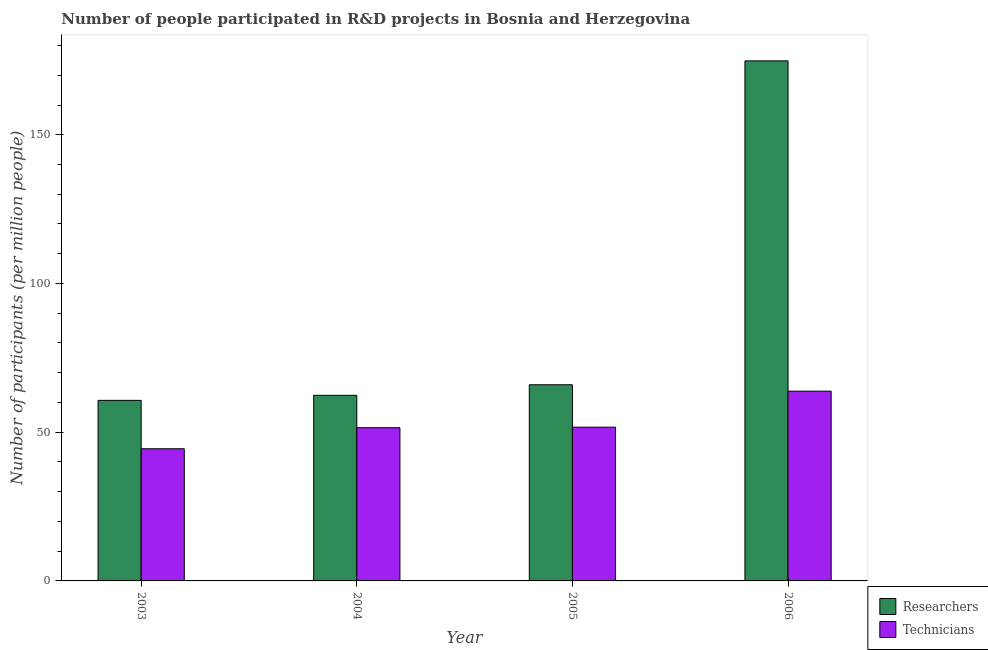Are the number of bars per tick equal to the number of legend labels?
Make the answer very short. Yes. How many bars are there on the 2nd tick from the left?
Offer a terse response. 2. How many bars are there on the 3rd tick from the right?
Provide a succinct answer. 2. What is the number of researchers in 2006?
Provide a short and direct response. 174.84. Across all years, what is the maximum number of technicians?
Make the answer very short. 63.8. Across all years, what is the minimum number of technicians?
Your answer should be compact. 44.43. In which year was the number of researchers maximum?
Keep it short and to the point. 2006. What is the total number of technicians in the graph?
Give a very brief answer. 211.44. What is the difference between the number of technicians in 2003 and that in 2006?
Ensure brevity in your answer.  -19.37. What is the difference between the number of researchers in 2005 and the number of technicians in 2004?
Offer a very short reply. 3.55. What is the average number of technicians per year?
Keep it short and to the point. 52.86. What is the ratio of the number of researchers in 2004 to that in 2005?
Provide a short and direct response. 0.95. Is the number of technicians in 2003 less than that in 2006?
Provide a succinct answer. Yes. What is the difference between the highest and the second highest number of technicians?
Offer a very short reply. 12.11. What is the difference between the highest and the lowest number of technicians?
Make the answer very short. 19.37. In how many years, is the number of researchers greater than the average number of researchers taken over all years?
Your answer should be compact. 1. Is the sum of the number of researchers in 2003 and 2005 greater than the maximum number of technicians across all years?
Keep it short and to the point. No. What does the 1st bar from the left in 2006 represents?
Provide a short and direct response. Researchers. What does the 2nd bar from the right in 2005 represents?
Make the answer very short. Researchers. How many bars are there?
Your answer should be very brief. 8. Are all the bars in the graph horizontal?
Provide a succinct answer. No. What is the difference between two consecutive major ticks on the Y-axis?
Provide a succinct answer. 50. Does the graph contain any zero values?
Your answer should be compact. No. Where does the legend appear in the graph?
Make the answer very short. Bottom right. How many legend labels are there?
Ensure brevity in your answer.  2. How are the legend labels stacked?
Your response must be concise. Vertical. What is the title of the graph?
Give a very brief answer. Number of people participated in R&D projects in Bosnia and Herzegovina. Does "Lowest 10% of population" appear as one of the legend labels in the graph?
Keep it short and to the point. No. What is the label or title of the Y-axis?
Provide a short and direct response. Number of participants (per million people). What is the Number of participants (per million people) in Researchers in 2003?
Keep it short and to the point. 60.7. What is the Number of participants (per million people) of Technicians in 2003?
Offer a terse response. 44.43. What is the Number of participants (per million people) in Researchers in 2004?
Keep it short and to the point. 62.41. What is the Number of participants (per million people) in Technicians in 2004?
Your answer should be compact. 51.51. What is the Number of participants (per million people) in Researchers in 2005?
Offer a very short reply. 65.95. What is the Number of participants (per million people) in Technicians in 2005?
Your answer should be compact. 51.7. What is the Number of participants (per million people) in Researchers in 2006?
Provide a short and direct response. 174.84. What is the Number of participants (per million people) of Technicians in 2006?
Your response must be concise. 63.8. Across all years, what is the maximum Number of participants (per million people) in Researchers?
Offer a terse response. 174.84. Across all years, what is the maximum Number of participants (per million people) in Technicians?
Give a very brief answer. 63.8. Across all years, what is the minimum Number of participants (per million people) of Researchers?
Your answer should be compact. 60.7. Across all years, what is the minimum Number of participants (per million people) in Technicians?
Ensure brevity in your answer.  44.43. What is the total Number of participants (per million people) of Researchers in the graph?
Ensure brevity in your answer.  363.9. What is the total Number of participants (per million people) in Technicians in the graph?
Your answer should be compact. 211.44. What is the difference between the Number of participants (per million people) in Researchers in 2003 and that in 2004?
Your answer should be compact. -1.7. What is the difference between the Number of participants (per million people) in Technicians in 2003 and that in 2004?
Ensure brevity in your answer.  -7.08. What is the difference between the Number of participants (per million people) in Researchers in 2003 and that in 2005?
Make the answer very short. -5.25. What is the difference between the Number of participants (per million people) of Technicians in 2003 and that in 2005?
Ensure brevity in your answer.  -7.26. What is the difference between the Number of participants (per million people) of Researchers in 2003 and that in 2006?
Your answer should be very brief. -114.14. What is the difference between the Number of participants (per million people) in Technicians in 2003 and that in 2006?
Ensure brevity in your answer.  -19.37. What is the difference between the Number of participants (per million people) in Researchers in 2004 and that in 2005?
Ensure brevity in your answer.  -3.55. What is the difference between the Number of participants (per million people) of Technicians in 2004 and that in 2005?
Ensure brevity in your answer.  -0.19. What is the difference between the Number of participants (per million people) of Researchers in 2004 and that in 2006?
Make the answer very short. -112.43. What is the difference between the Number of participants (per million people) in Technicians in 2004 and that in 2006?
Your answer should be very brief. -12.29. What is the difference between the Number of participants (per million people) in Researchers in 2005 and that in 2006?
Offer a very short reply. -108.89. What is the difference between the Number of participants (per million people) in Technicians in 2005 and that in 2006?
Your response must be concise. -12.11. What is the difference between the Number of participants (per million people) of Researchers in 2003 and the Number of participants (per million people) of Technicians in 2004?
Make the answer very short. 9.19. What is the difference between the Number of participants (per million people) in Researchers in 2003 and the Number of participants (per million people) in Technicians in 2005?
Make the answer very short. 9.01. What is the difference between the Number of participants (per million people) of Researchers in 2003 and the Number of participants (per million people) of Technicians in 2006?
Make the answer very short. -3.1. What is the difference between the Number of participants (per million people) of Researchers in 2004 and the Number of participants (per million people) of Technicians in 2005?
Keep it short and to the point. 10.71. What is the difference between the Number of participants (per million people) of Researchers in 2004 and the Number of participants (per million people) of Technicians in 2006?
Make the answer very short. -1.4. What is the difference between the Number of participants (per million people) in Researchers in 2005 and the Number of participants (per million people) in Technicians in 2006?
Your response must be concise. 2.15. What is the average Number of participants (per million people) of Researchers per year?
Give a very brief answer. 90.97. What is the average Number of participants (per million people) of Technicians per year?
Offer a very short reply. 52.86. In the year 2003, what is the difference between the Number of participants (per million people) in Researchers and Number of participants (per million people) in Technicians?
Make the answer very short. 16.27. In the year 2004, what is the difference between the Number of participants (per million people) of Researchers and Number of participants (per million people) of Technicians?
Your answer should be compact. 10.89. In the year 2005, what is the difference between the Number of participants (per million people) in Researchers and Number of participants (per million people) in Technicians?
Make the answer very short. 14.25. In the year 2006, what is the difference between the Number of participants (per million people) in Researchers and Number of participants (per million people) in Technicians?
Ensure brevity in your answer.  111.04. What is the ratio of the Number of participants (per million people) in Researchers in 2003 to that in 2004?
Provide a short and direct response. 0.97. What is the ratio of the Number of participants (per million people) of Technicians in 2003 to that in 2004?
Provide a short and direct response. 0.86. What is the ratio of the Number of participants (per million people) of Researchers in 2003 to that in 2005?
Your response must be concise. 0.92. What is the ratio of the Number of participants (per million people) in Technicians in 2003 to that in 2005?
Your answer should be compact. 0.86. What is the ratio of the Number of participants (per million people) of Researchers in 2003 to that in 2006?
Provide a short and direct response. 0.35. What is the ratio of the Number of participants (per million people) of Technicians in 2003 to that in 2006?
Make the answer very short. 0.7. What is the ratio of the Number of participants (per million people) in Researchers in 2004 to that in 2005?
Ensure brevity in your answer.  0.95. What is the ratio of the Number of participants (per million people) of Researchers in 2004 to that in 2006?
Keep it short and to the point. 0.36. What is the ratio of the Number of participants (per million people) of Technicians in 2004 to that in 2006?
Keep it short and to the point. 0.81. What is the ratio of the Number of participants (per million people) in Researchers in 2005 to that in 2006?
Offer a terse response. 0.38. What is the ratio of the Number of participants (per million people) of Technicians in 2005 to that in 2006?
Make the answer very short. 0.81. What is the difference between the highest and the second highest Number of participants (per million people) of Researchers?
Make the answer very short. 108.89. What is the difference between the highest and the second highest Number of participants (per million people) of Technicians?
Give a very brief answer. 12.11. What is the difference between the highest and the lowest Number of participants (per million people) of Researchers?
Offer a terse response. 114.14. What is the difference between the highest and the lowest Number of participants (per million people) of Technicians?
Make the answer very short. 19.37. 